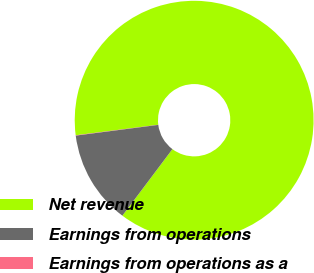Convert chart to OTSL. <chart><loc_0><loc_0><loc_500><loc_500><pie_chart><fcel>Net revenue<fcel>Earnings from operations<fcel>Earnings from operations as a<nl><fcel>87.27%<fcel>12.69%<fcel>0.04%<nl></chart> 